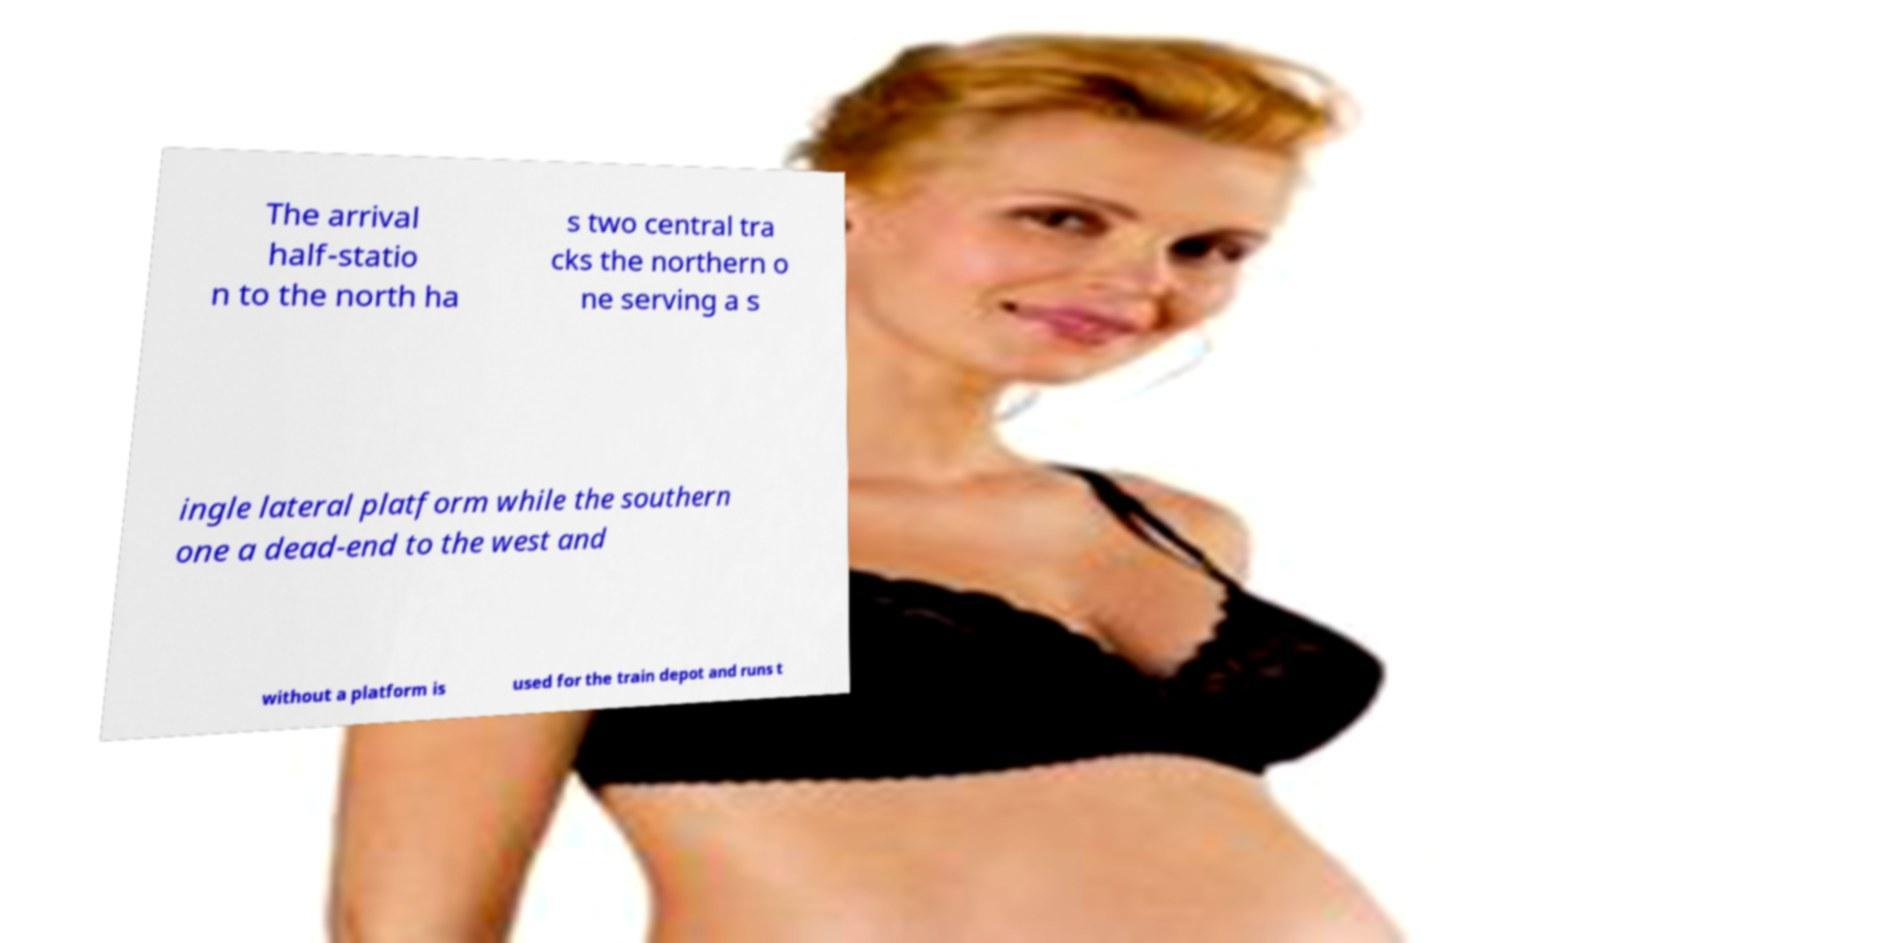What messages or text are displayed in this image? I need them in a readable, typed format. The arrival half-statio n to the north ha s two central tra cks the northern o ne serving a s ingle lateral platform while the southern one a dead-end to the west and without a platform is used for the train depot and runs t 